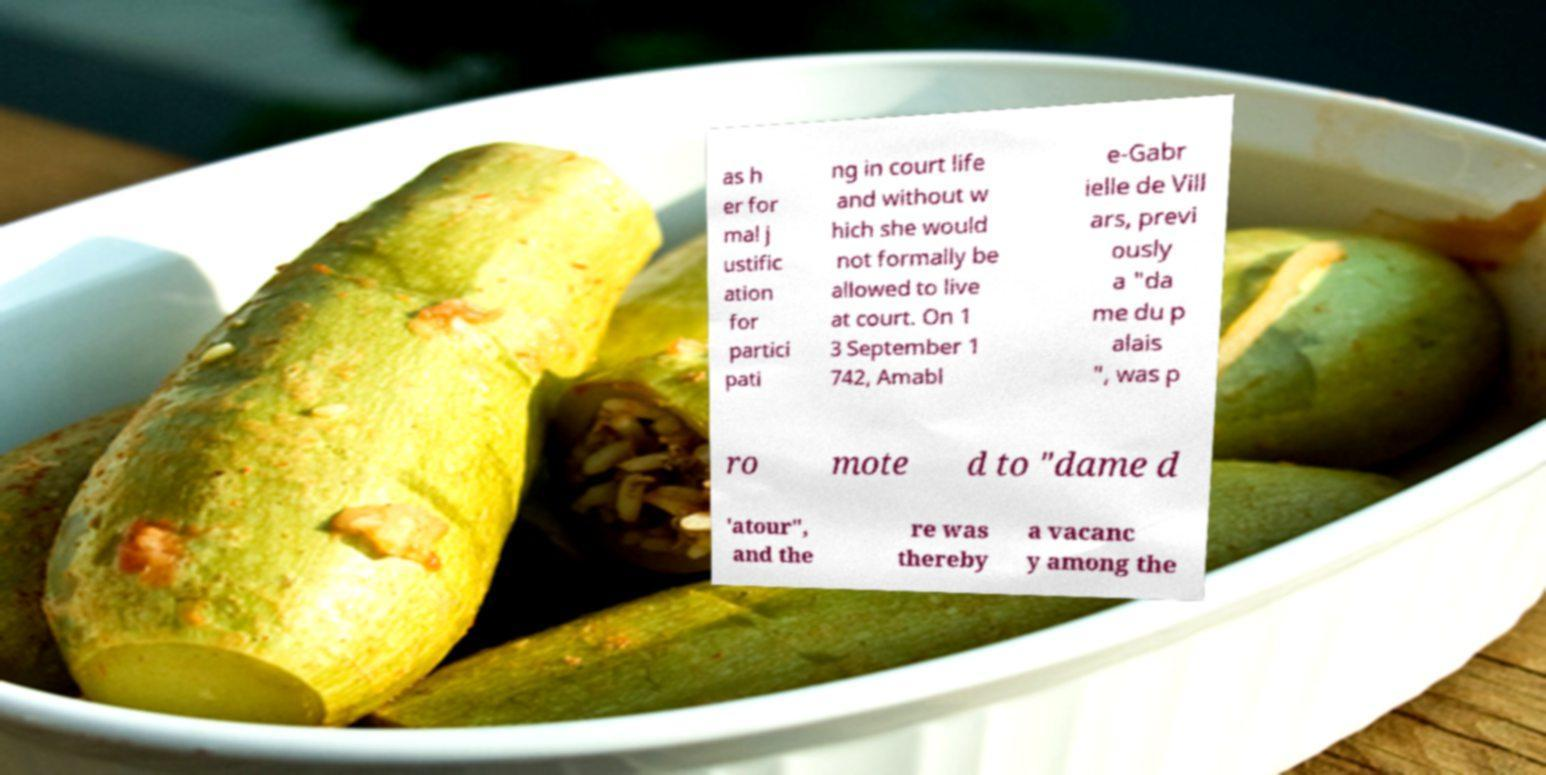There's text embedded in this image that I need extracted. Can you transcribe it verbatim? as h er for mal j ustific ation for partici pati ng in court life and without w hich she would not formally be allowed to live at court. On 1 3 September 1 742, Amabl e-Gabr ielle de Vill ars, previ ously a "da me du p alais ", was p ro mote d to "dame d 'atour", and the re was thereby a vacanc y among the 